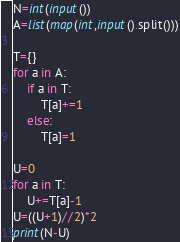Convert code to text. <code><loc_0><loc_0><loc_500><loc_500><_Python_>N=int(input())
A=list(map(int,input().split()))

T={}
for a in A:
    if a in T:
        T[a]+=1
    else:
        T[a]=1

U=0
for a in T:
    U+=T[a]-1
U=((U+1)//2)*2
print(N-U)
</code> 